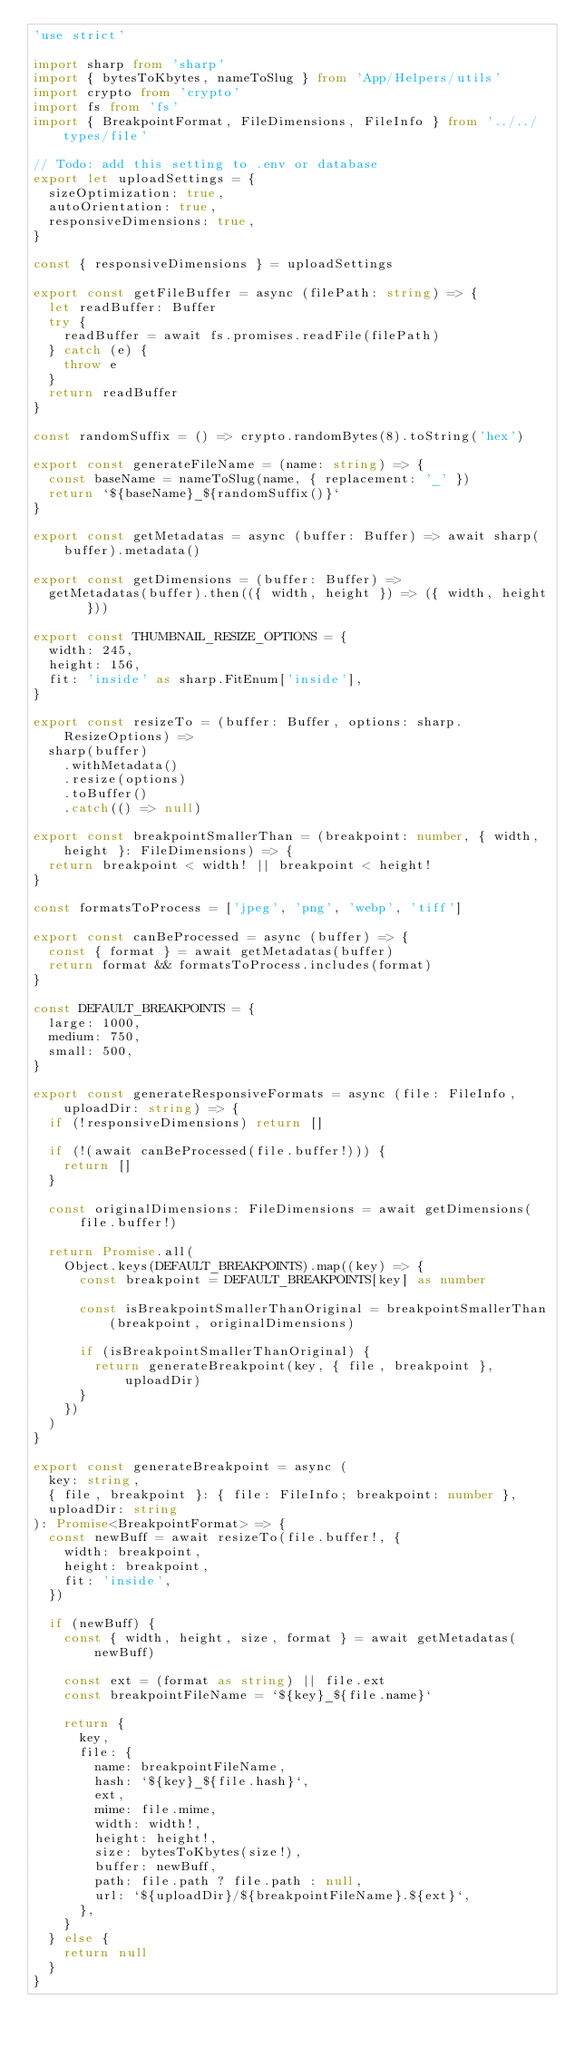<code> <loc_0><loc_0><loc_500><loc_500><_TypeScript_>'use strict'

import sharp from 'sharp'
import { bytesToKbytes, nameToSlug } from 'App/Helpers/utils'
import crypto from 'crypto'
import fs from 'fs'
import { BreakpointFormat, FileDimensions, FileInfo } from '../../types/file'

// Todo: add this setting to .env or database
export let uploadSettings = {
  sizeOptimization: true,
  autoOrientation: true,
  responsiveDimensions: true,
}

const { responsiveDimensions } = uploadSettings

export const getFileBuffer = async (filePath: string) => {
  let readBuffer: Buffer
  try {
    readBuffer = await fs.promises.readFile(filePath)
  } catch (e) {
    throw e
  }
  return readBuffer
}

const randomSuffix = () => crypto.randomBytes(8).toString('hex')

export const generateFileName = (name: string) => {
  const baseName = nameToSlug(name, { replacement: '_' })
  return `${baseName}_${randomSuffix()}`
}

export const getMetadatas = async (buffer: Buffer) => await sharp(buffer).metadata()

export const getDimensions = (buffer: Buffer) =>
  getMetadatas(buffer).then(({ width, height }) => ({ width, height }))

export const THUMBNAIL_RESIZE_OPTIONS = {
  width: 245,
  height: 156,
  fit: 'inside' as sharp.FitEnum['inside'],
}

export const resizeTo = (buffer: Buffer, options: sharp.ResizeOptions) =>
  sharp(buffer)
    .withMetadata()
    .resize(options)
    .toBuffer()
    .catch(() => null)

export const breakpointSmallerThan = (breakpoint: number, { width, height }: FileDimensions) => {
  return breakpoint < width! || breakpoint < height!
}

const formatsToProcess = ['jpeg', 'png', 'webp', 'tiff']

export const canBeProcessed = async (buffer) => {
  const { format } = await getMetadatas(buffer)
  return format && formatsToProcess.includes(format)
}

const DEFAULT_BREAKPOINTS = {
  large: 1000,
  medium: 750,
  small: 500,
}

export const generateResponsiveFormats = async (file: FileInfo, uploadDir: string) => {
  if (!responsiveDimensions) return []

  if (!(await canBeProcessed(file.buffer!))) {
    return []
  }

  const originalDimensions: FileDimensions = await getDimensions(file.buffer!)

  return Promise.all(
    Object.keys(DEFAULT_BREAKPOINTS).map((key) => {
      const breakpoint = DEFAULT_BREAKPOINTS[key] as number

      const isBreakpointSmallerThanOriginal = breakpointSmallerThan(breakpoint, originalDimensions)

      if (isBreakpointSmallerThanOriginal) {
        return generateBreakpoint(key, { file, breakpoint }, uploadDir)
      }
    })
  )
}

export const generateBreakpoint = async (
  key: string,
  { file, breakpoint }: { file: FileInfo; breakpoint: number },
  uploadDir: string
): Promise<BreakpointFormat> => {
  const newBuff = await resizeTo(file.buffer!, {
    width: breakpoint,
    height: breakpoint,
    fit: 'inside',
  })

  if (newBuff) {
    const { width, height, size, format } = await getMetadatas(newBuff)

    const ext = (format as string) || file.ext
    const breakpointFileName = `${key}_${file.name}`

    return {
      key,
      file: {
        name: breakpointFileName,
        hash: `${key}_${file.hash}`,
        ext,
        mime: file.mime,
        width: width!,
        height: height!,
        size: bytesToKbytes(size!),
        buffer: newBuff,
        path: file.path ? file.path : null,
        url: `${uploadDir}/${breakpointFileName}.${ext}`,
      },
    }
  } else {
    return null
  }
}
</code> 